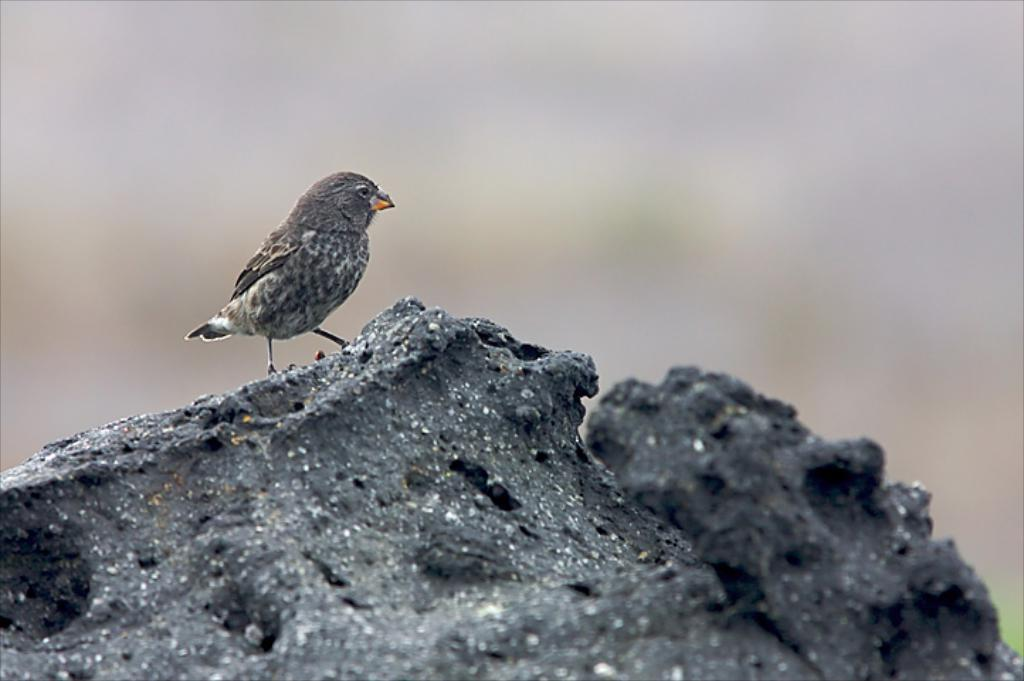What type of animal is present in the image? There is a bird in the image. What is the bird standing on in the image? The bird is on a rock. Where is the bird and rock located in the image? The bird and rock are in the center of the image. What type of cake is visible in the image? There is no cake present in the image. Is the bird wearing silk clothing in the image? There is no indication of clothing, silk or otherwise, on the bird in the image. 